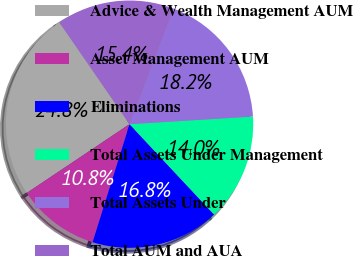<chart> <loc_0><loc_0><loc_500><loc_500><pie_chart><fcel>Advice & Wealth Management AUM<fcel>Asset Management AUM<fcel>Eliminations<fcel>Total Assets Under Management<fcel>Total Assets Under<fcel>Total AUM and AUA<nl><fcel>24.78%<fcel>10.78%<fcel>16.81%<fcel>14.01%<fcel>18.21%<fcel>15.41%<nl></chart> 